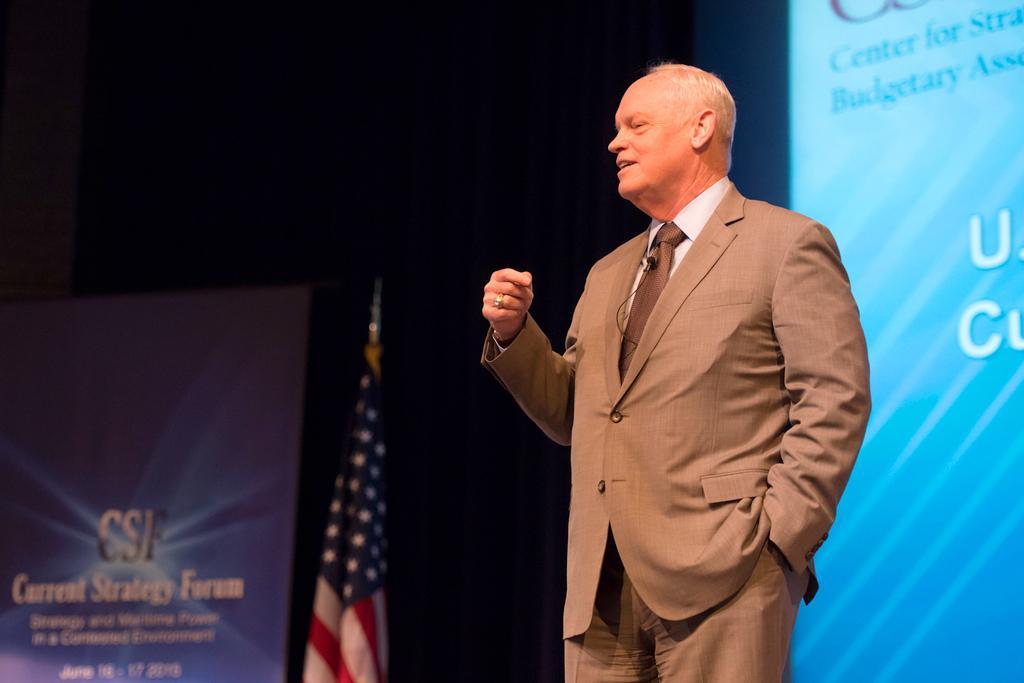Please provide a concise description of this image. In this image we can see a man is standing. He is wearing a suit. In the background, we can see a screen, a banner and a flag. 